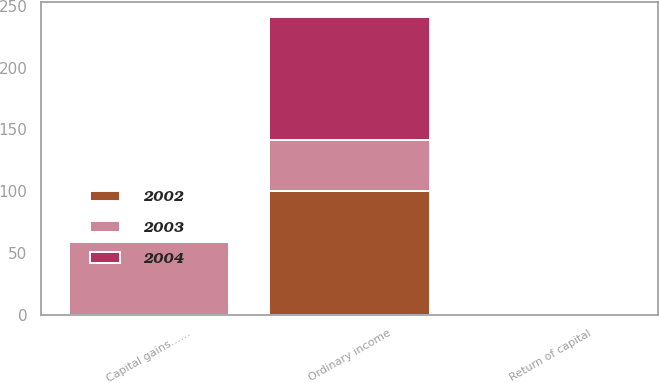Convert chart to OTSL. <chart><loc_0><loc_0><loc_500><loc_500><stacked_bar_chart><ecel><fcel>Ordinary income<fcel>Capital gains……<fcel>Return of capital<nl><fcel>2003<fcel>41.4<fcel>58.6<fcel>0<nl><fcel>2004<fcel>100<fcel>0<fcel>0<nl><fcel>2002<fcel>100<fcel>0<fcel>0<nl></chart> 